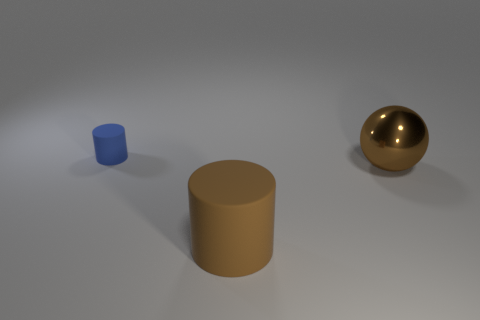Are there any other things that have the same size as the blue object?
Offer a very short reply. No. How many big things are either blue things or cyan shiny balls?
Your answer should be compact. 0. Is the material of the blue cylinder the same as the brown sphere?
Your answer should be very brief. No. Are there any metallic balls of the same color as the tiny cylinder?
Offer a very short reply. No. What is the size of the brown object that is made of the same material as the blue thing?
Provide a succinct answer. Large. There is a rubber object to the right of the cylinder on the left side of the rubber thing in front of the small blue matte cylinder; what is its shape?
Offer a terse response. Cylinder. There is another rubber object that is the same shape as the small blue matte thing; what size is it?
Ensure brevity in your answer.  Large. There is a thing that is both in front of the blue object and left of the brown shiny object; what size is it?
Provide a succinct answer. Large. What shape is the big rubber thing that is the same color as the shiny thing?
Provide a short and direct response. Cylinder. What color is the tiny object?
Ensure brevity in your answer.  Blue. 